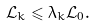<formula> <loc_0><loc_0><loc_500><loc_500>\mathcal { L } _ { k } \leqslant \lambda _ { k } \mathcal { L } _ { 0 } .</formula> 